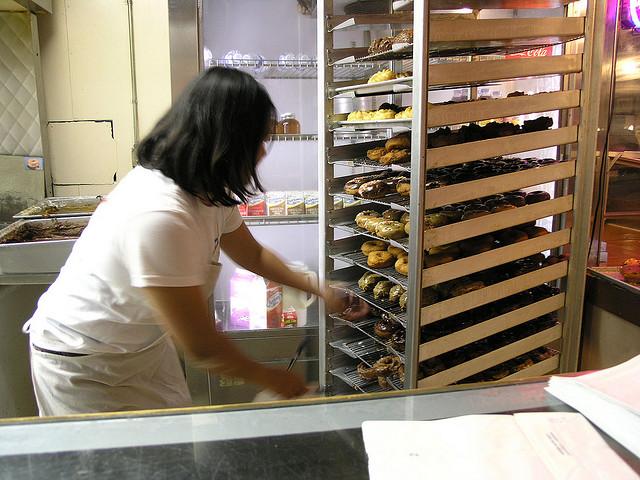Is the woman fighting the trays?
Concise answer only. No. What color shirt is this person wearing?
Quick response, please. White. Is the woman serving breakfast?
Be succinct. Yes. 